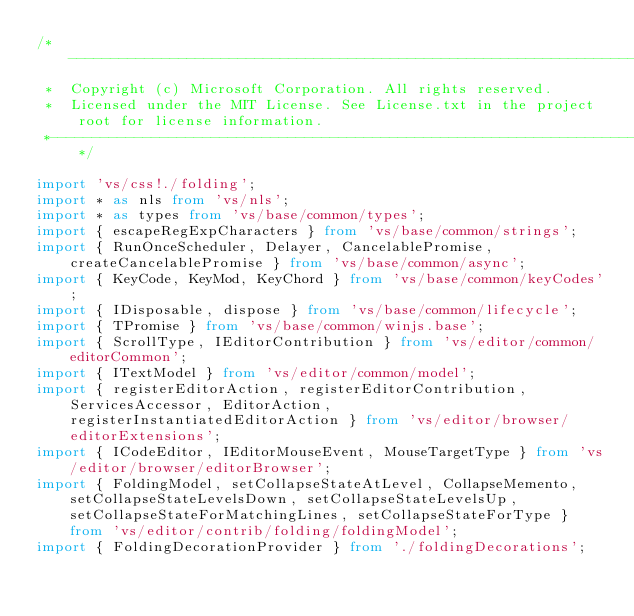Convert code to text. <code><loc_0><loc_0><loc_500><loc_500><_TypeScript_>/*---------------------------------------------------------------------------------------------
 *  Copyright (c) Microsoft Corporation. All rights reserved.
 *  Licensed under the MIT License. See License.txt in the project root for license information.
 *--------------------------------------------------------------------------------------------*/

import 'vs/css!./folding';
import * as nls from 'vs/nls';
import * as types from 'vs/base/common/types';
import { escapeRegExpCharacters } from 'vs/base/common/strings';
import { RunOnceScheduler, Delayer, CancelablePromise, createCancelablePromise } from 'vs/base/common/async';
import { KeyCode, KeyMod, KeyChord } from 'vs/base/common/keyCodes';
import { IDisposable, dispose } from 'vs/base/common/lifecycle';
import { TPromise } from 'vs/base/common/winjs.base';
import { ScrollType, IEditorContribution } from 'vs/editor/common/editorCommon';
import { ITextModel } from 'vs/editor/common/model';
import { registerEditorAction, registerEditorContribution, ServicesAccessor, EditorAction, registerInstantiatedEditorAction } from 'vs/editor/browser/editorExtensions';
import { ICodeEditor, IEditorMouseEvent, MouseTargetType } from 'vs/editor/browser/editorBrowser';
import { FoldingModel, setCollapseStateAtLevel, CollapseMemento, setCollapseStateLevelsDown, setCollapseStateLevelsUp, setCollapseStateForMatchingLines, setCollapseStateForType } from 'vs/editor/contrib/folding/foldingModel';
import { FoldingDecorationProvider } from './foldingDecorations';</code> 